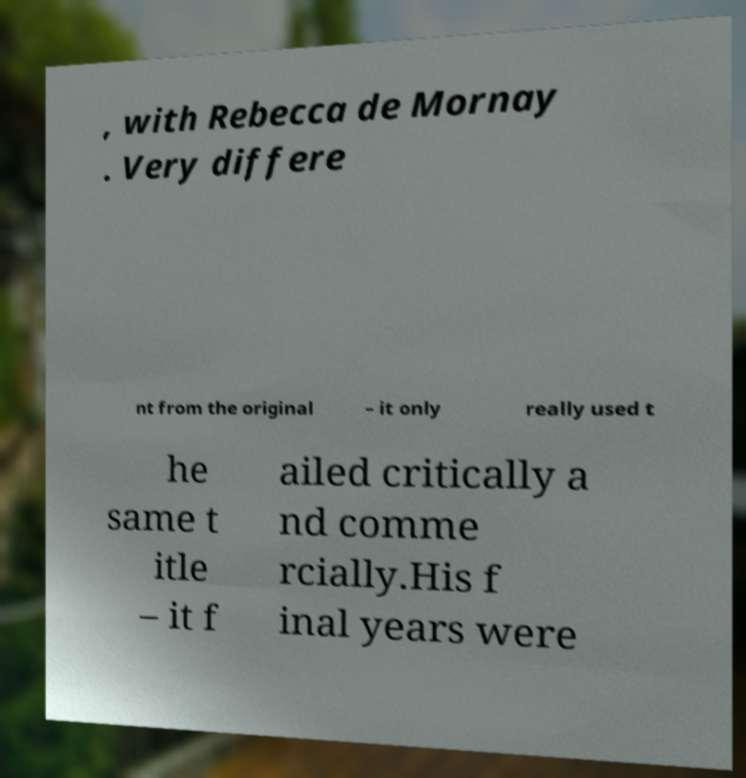Can you read and provide the text displayed in the image?This photo seems to have some interesting text. Can you extract and type it out for me? , with Rebecca de Mornay . Very differe nt from the original – it only really used t he same t itle – it f ailed critically a nd comme rcially.His f inal years were 